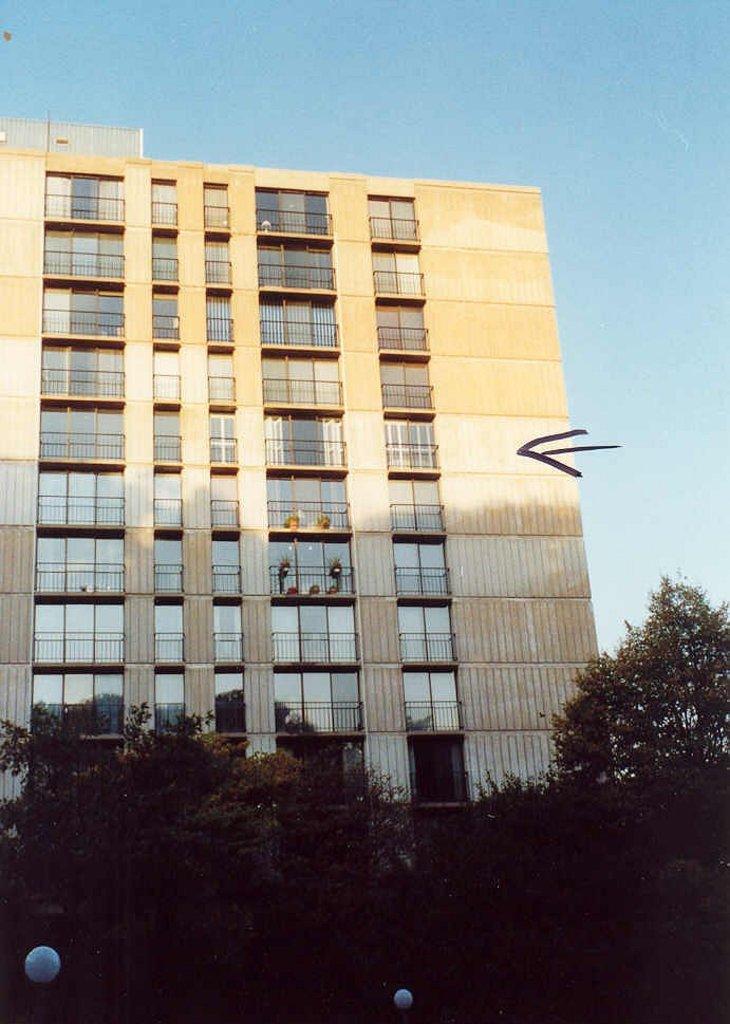Can you describe this image briefly? In this image there are some trees at bottom of this image and there is a building in middle of this image. There is a sky at top of this image ,There are some lights are at bottom of this image. 